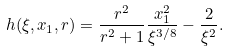<formula> <loc_0><loc_0><loc_500><loc_500>h ( \xi , x _ { 1 } , r ) = \frac { r ^ { 2 } } { r ^ { 2 } + 1 } \frac { x _ { 1 } ^ { 2 } } { \xi ^ { 3 / 8 } } - \frac { 2 } { \xi ^ { 2 } } .</formula> 